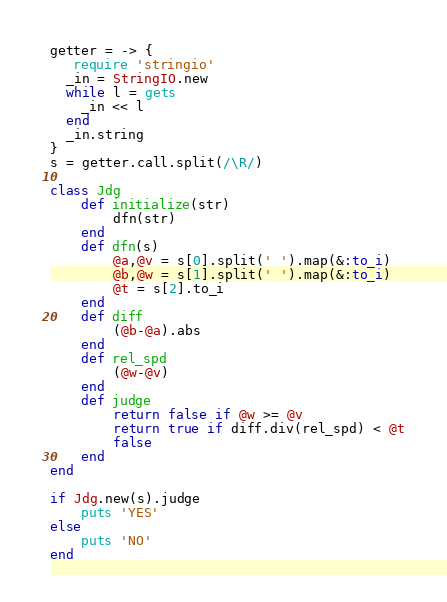<code> <loc_0><loc_0><loc_500><loc_500><_Ruby_>getter = -> {
   require 'stringio'
  _in = StringIO.new
  while l = gets
    _in << l
  end
  _in.string
}
s = getter.call.split(/\R/)

class Jdg
    def initialize(str)
        dfn(str)
    end
    def dfn(s)
        @a,@v = s[0].split(' ').map(&:to_i)
        @b,@w = s[1].split(' ').map(&:to_i)
        @t = s[2].to_i
    end
    def diff
        (@b-@a).abs
    end
    def rel_spd
        (@w-@v)
    end
    def judge
        return false if @w >= @v
        return true if diff.div(rel_spd) < @t
        false
    end
end

if Jdg.new(s).judge
    puts 'YES'
else
    puts 'NO'
end</code> 